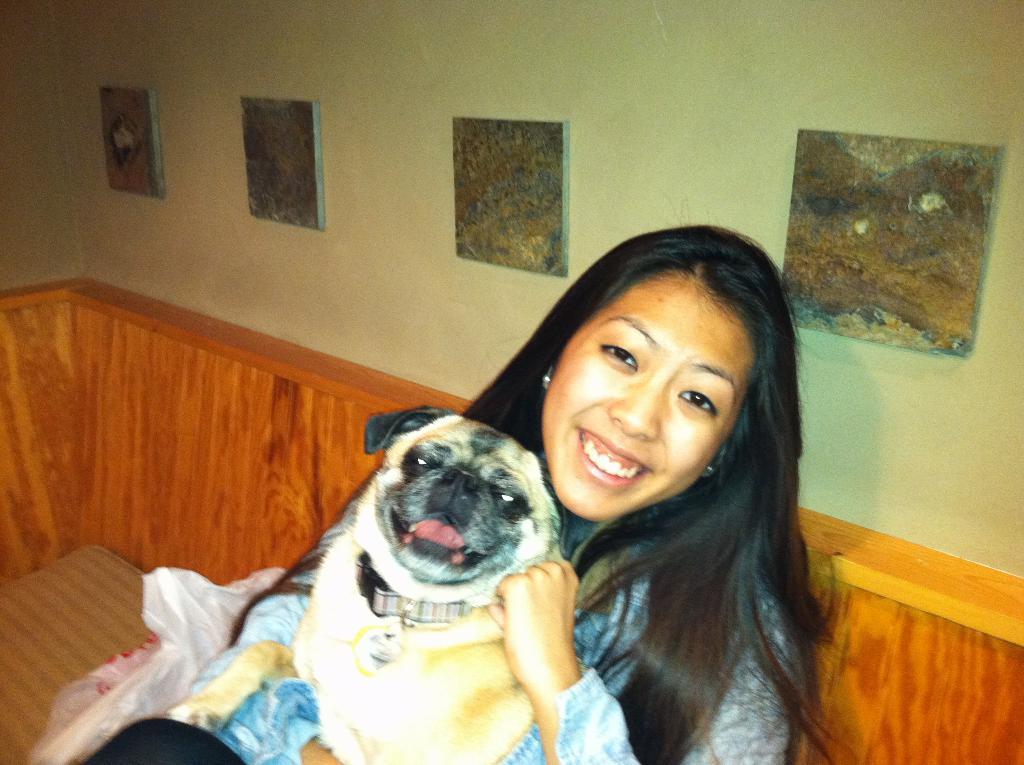How would you summarize this image in a sentence or two? In the image we can see there is a woman who is holding a pug dog in her lap. 